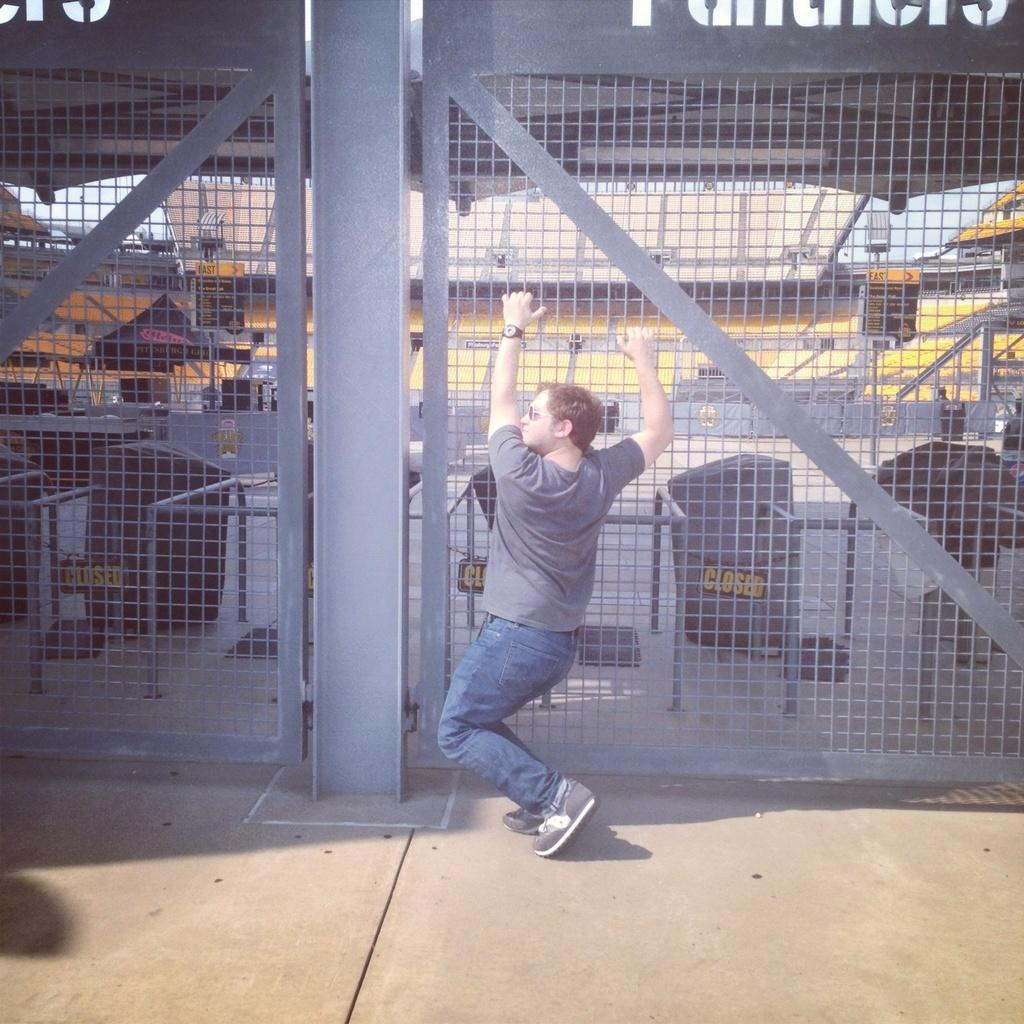What is the main subject of the image? There is a man standing in the image. What is the man holding in the image? The man is holding a fencing. What can be seen in the background of the image? There is a building in the background of the image. What type of mist can be seen in the bedroom in the image? There is no bedroom or mist present in the image; it features a man holding a fencing with a building in the background. 